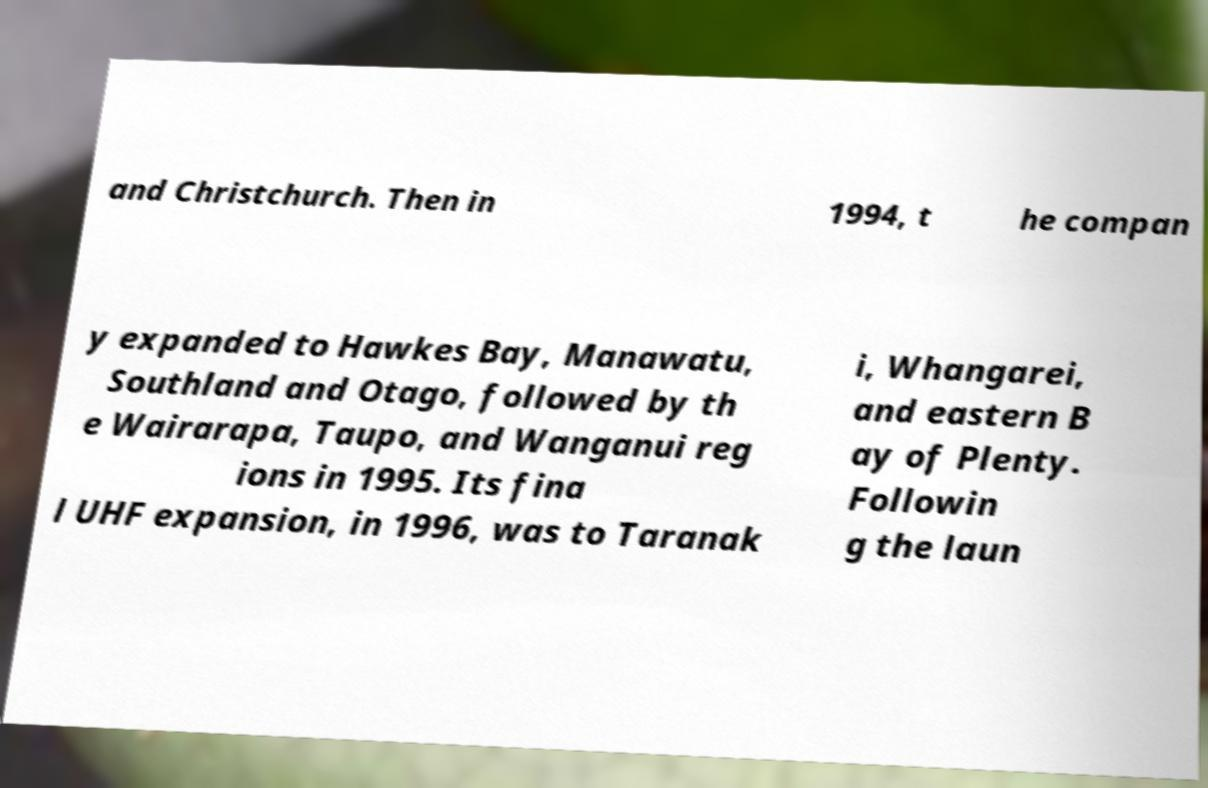There's text embedded in this image that I need extracted. Can you transcribe it verbatim? and Christchurch. Then in 1994, t he compan y expanded to Hawkes Bay, Manawatu, Southland and Otago, followed by th e Wairarapa, Taupo, and Wanganui reg ions in 1995. Its fina l UHF expansion, in 1996, was to Taranak i, Whangarei, and eastern B ay of Plenty. Followin g the laun 